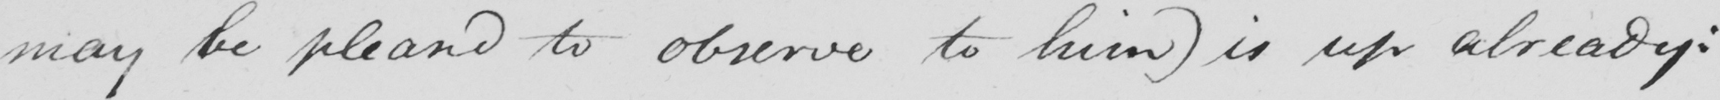Transcribe the text shown in this historical manuscript line. may be pleased to observe to him )  is up already : 